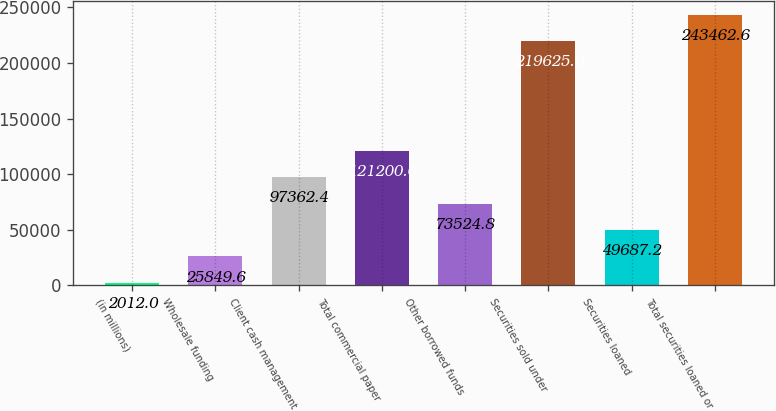Convert chart. <chart><loc_0><loc_0><loc_500><loc_500><bar_chart><fcel>(in millions)<fcel>Wholesale funding<fcel>Client cash management<fcel>Total commercial paper<fcel>Other borrowed funds<fcel>Securities sold under<fcel>Securities loaned<fcel>Total securities loaned or<nl><fcel>2012<fcel>25849.6<fcel>97362.4<fcel>121200<fcel>73524.8<fcel>219625<fcel>49687.2<fcel>243463<nl></chart> 